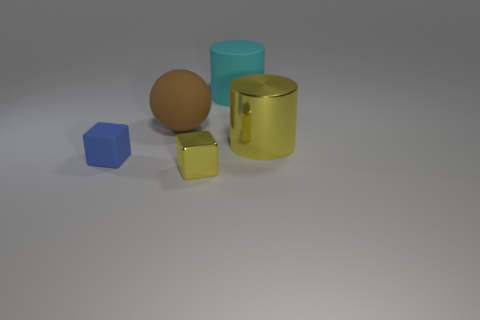Add 1 small gray cubes. How many objects exist? 6 Subtract all balls. How many objects are left? 4 Add 1 large shiny things. How many large shiny things are left? 2 Add 3 big red metal spheres. How many big red metal spheres exist? 3 Subtract 0 purple cylinders. How many objects are left? 5 Subtract all brown matte balls. Subtract all metallic cubes. How many objects are left? 3 